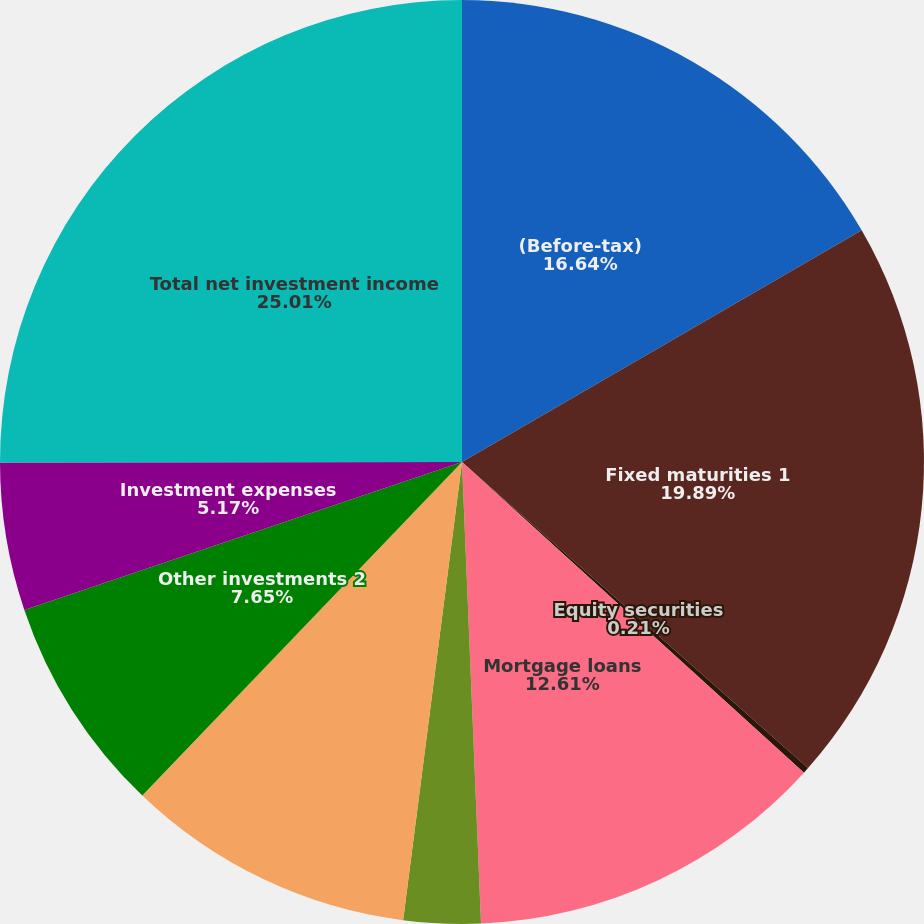Convert chart to OTSL. <chart><loc_0><loc_0><loc_500><loc_500><pie_chart><fcel>(Before-tax)<fcel>Fixed maturities 1<fcel>Equity securities<fcel>Mortgage loans<fcel>Policy loans<fcel>Limited partnerships and other<fcel>Other investments 2<fcel>Investment expenses<fcel>Total net investment income<nl><fcel>16.64%<fcel>19.89%<fcel>0.21%<fcel>12.61%<fcel>2.69%<fcel>10.13%<fcel>7.65%<fcel>5.17%<fcel>25.02%<nl></chart> 